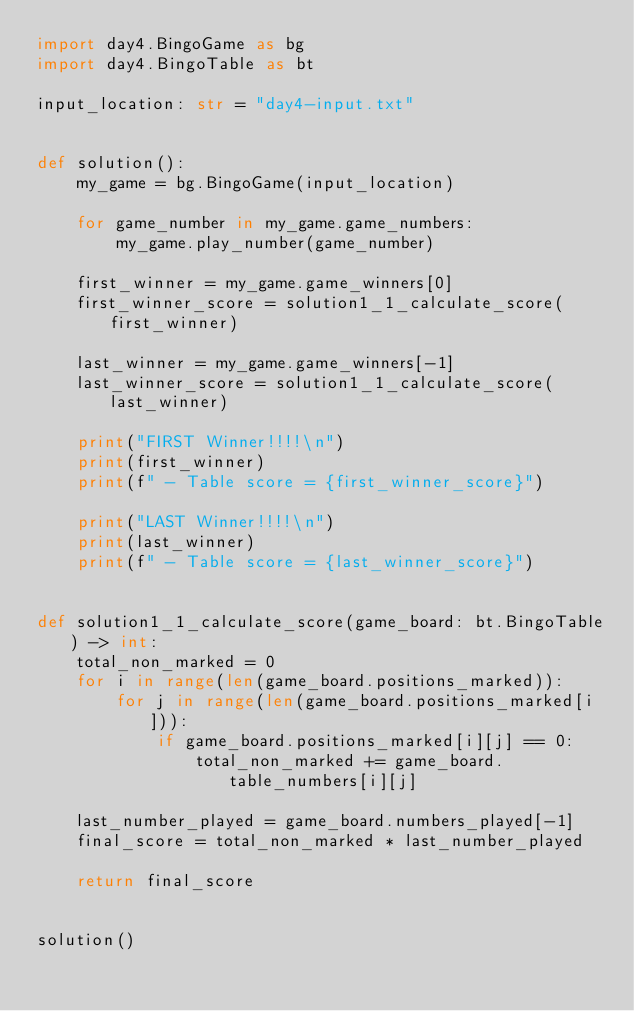Convert code to text. <code><loc_0><loc_0><loc_500><loc_500><_Python_>import day4.BingoGame as bg
import day4.BingoTable as bt

input_location: str = "day4-input.txt"


def solution():
    my_game = bg.BingoGame(input_location)

    for game_number in my_game.game_numbers:
        my_game.play_number(game_number)

    first_winner = my_game.game_winners[0]
    first_winner_score = solution1_1_calculate_score(first_winner)

    last_winner = my_game.game_winners[-1]
    last_winner_score = solution1_1_calculate_score(last_winner)

    print("FIRST Winner!!!!\n")
    print(first_winner)
    print(f" - Table score = {first_winner_score}")

    print("LAST Winner!!!!\n")
    print(last_winner)
    print(f" - Table score = {last_winner_score}")


def solution1_1_calculate_score(game_board: bt.BingoTable) -> int:
    total_non_marked = 0
    for i in range(len(game_board.positions_marked)):
        for j in range(len(game_board.positions_marked[i])):
            if game_board.positions_marked[i][j] == 0:
                total_non_marked += game_board.table_numbers[i][j]

    last_number_played = game_board.numbers_played[-1]
    final_score = total_non_marked * last_number_played

    return final_score


solution()
</code> 